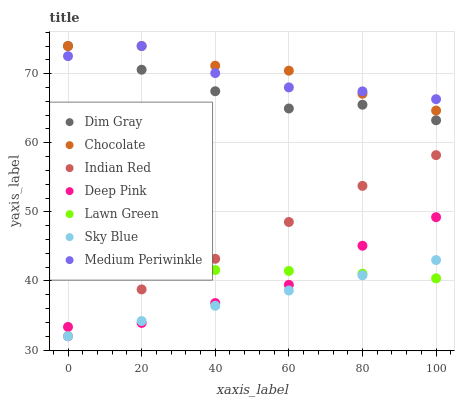Does Sky Blue have the minimum area under the curve?
Answer yes or no. Yes. Does Chocolate have the maximum area under the curve?
Answer yes or no. Yes. Does Dim Gray have the minimum area under the curve?
Answer yes or no. No. Does Dim Gray have the maximum area under the curve?
Answer yes or no. No. Is Sky Blue the smoothest?
Answer yes or no. Yes. Is Medium Periwinkle the roughest?
Answer yes or no. Yes. Is Dim Gray the smoothest?
Answer yes or no. No. Is Dim Gray the roughest?
Answer yes or no. No. Does Indian Red have the lowest value?
Answer yes or no. Yes. Does Dim Gray have the lowest value?
Answer yes or no. No. Does Chocolate have the highest value?
Answer yes or no. Yes. Does Deep Pink have the highest value?
Answer yes or no. No. Is Indian Red less than Chocolate?
Answer yes or no. Yes. Is Chocolate greater than Lawn Green?
Answer yes or no. Yes. Does Dim Gray intersect Chocolate?
Answer yes or no. Yes. Is Dim Gray less than Chocolate?
Answer yes or no. No. Is Dim Gray greater than Chocolate?
Answer yes or no. No. Does Indian Red intersect Chocolate?
Answer yes or no. No. 